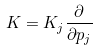<formula> <loc_0><loc_0><loc_500><loc_500>K = K _ { j } \frac { \partial } { \partial p _ { j } }</formula> 